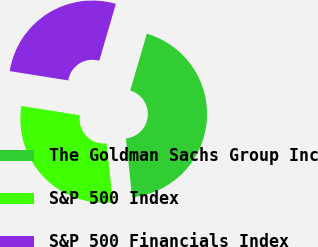Convert chart. <chart><loc_0><loc_0><loc_500><loc_500><pie_chart><fcel>The Goldman Sachs Group Inc<fcel>S&P 500 Index<fcel>S&P 500 Financials Index<nl><fcel>43.81%<fcel>29.18%<fcel>27.01%<nl></chart> 